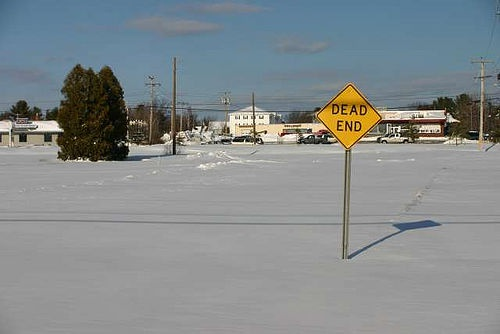Describe the objects in this image and their specific colors. I can see truck in blue, darkgray, black, gray, and ivory tones, truck in blue, black, gray, and darkgray tones, car in blue, black, gray, darkgreen, and tan tones, car in blue, black, gray, and darkgray tones, and car in blue, black, darkgray, and gray tones in this image. 